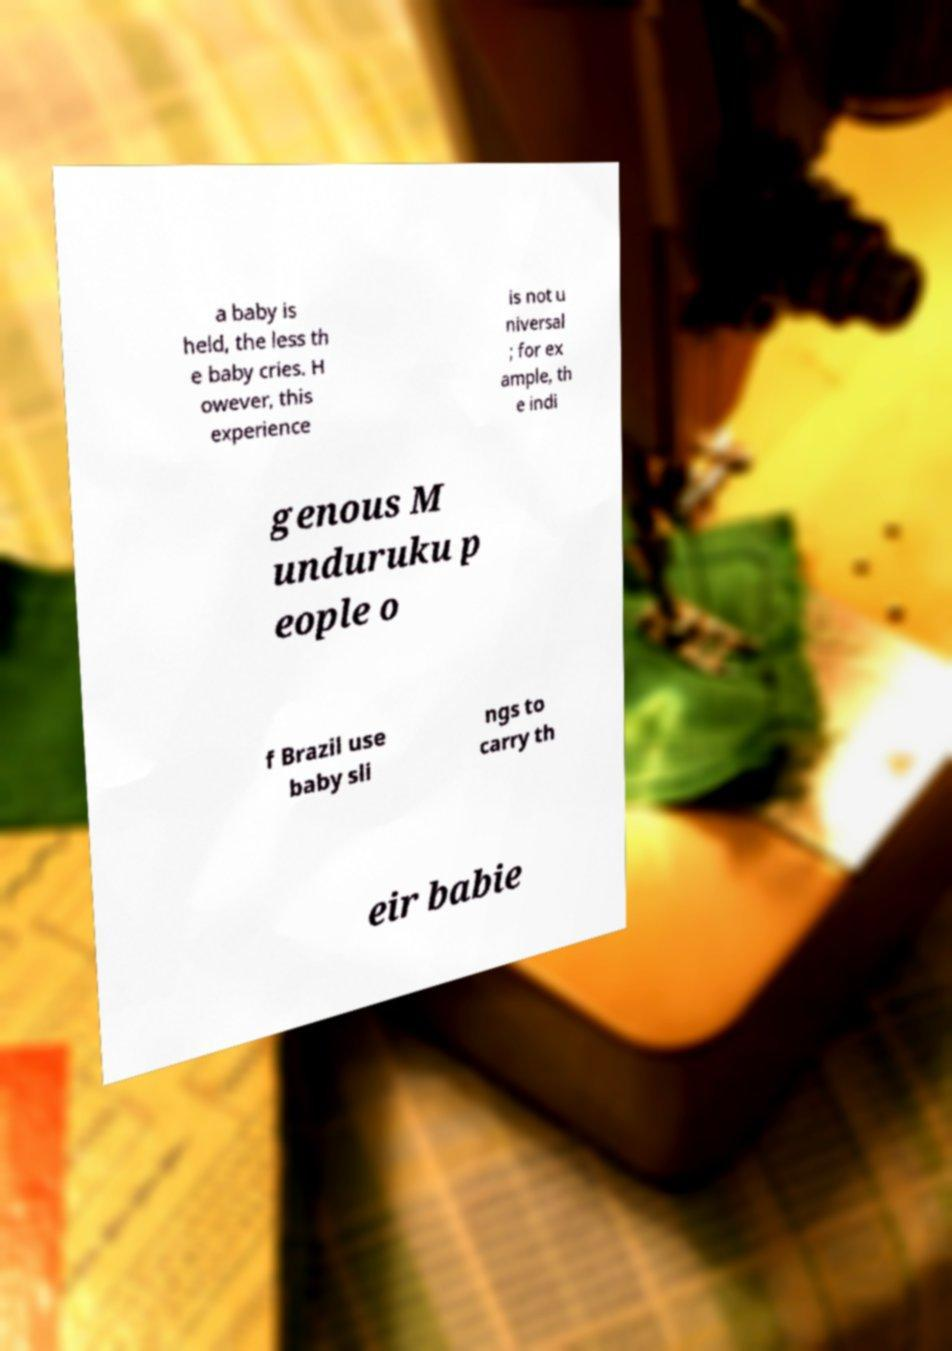What messages or text are displayed in this image? I need them in a readable, typed format. a baby is held, the less th e baby cries. H owever, this experience is not u niversal ; for ex ample, th e indi genous M unduruku p eople o f Brazil use baby sli ngs to carry th eir babie 